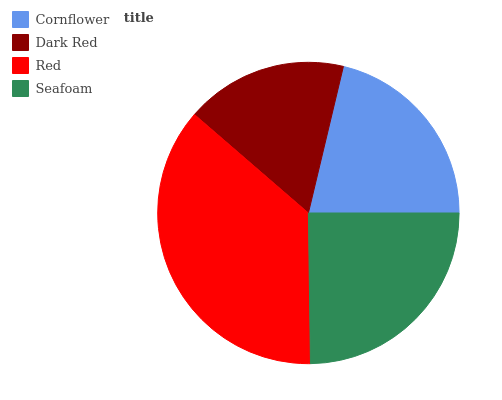Is Dark Red the minimum?
Answer yes or no. Yes. Is Red the maximum?
Answer yes or no. Yes. Is Red the minimum?
Answer yes or no. No. Is Dark Red the maximum?
Answer yes or no. No. Is Red greater than Dark Red?
Answer yes or no. Yes. Is Dark Red less than Red?
Answer yes or no. Yes. Is Dark Red greater than Red?
Answer yes or no. No. Is Red less than Dark Red?
Answer yes or no. No. Is Seafoam the high median?
Answer yes or no. Yes. Is Cornflower the low median?
Answer yes or no. Yes. Is Dark Red the high median?
Answer yes or no. No. Is Red the low median?
Answer yes or no. No. 